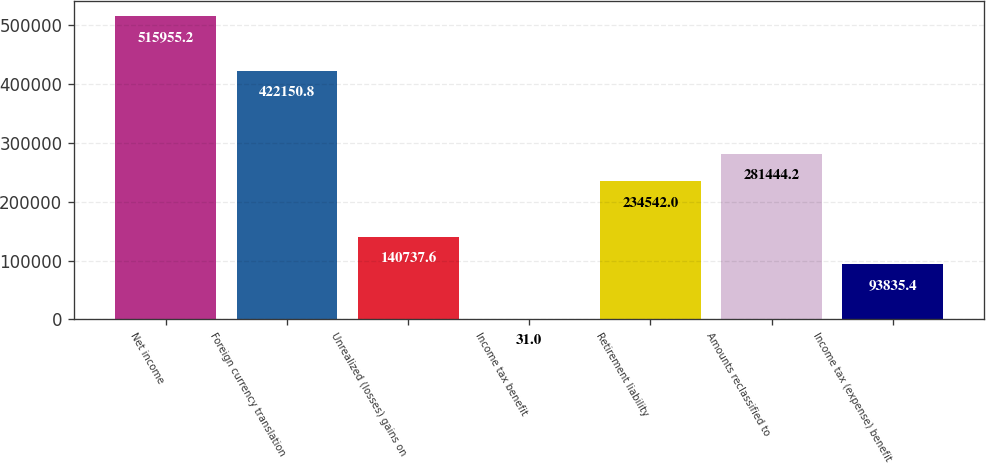Convert chart to OTSL. <chart><loc_0><loc_0><loc_500><loc_500><bar_chart><fcel>Net income<fcel>Foreign currency translation<fcel>Unrealized (losses) gains on<fcel>Income tax benefit<fcel>Retirement liability<fcel>Amounts reclassified to<fcel>Income tax (expense) benefit<nl><fcel>515955<fcel>422151<fcel>140738<fcel>31<fcel>234542<fcel>281444<fcel>93835.4<nl></chart> 